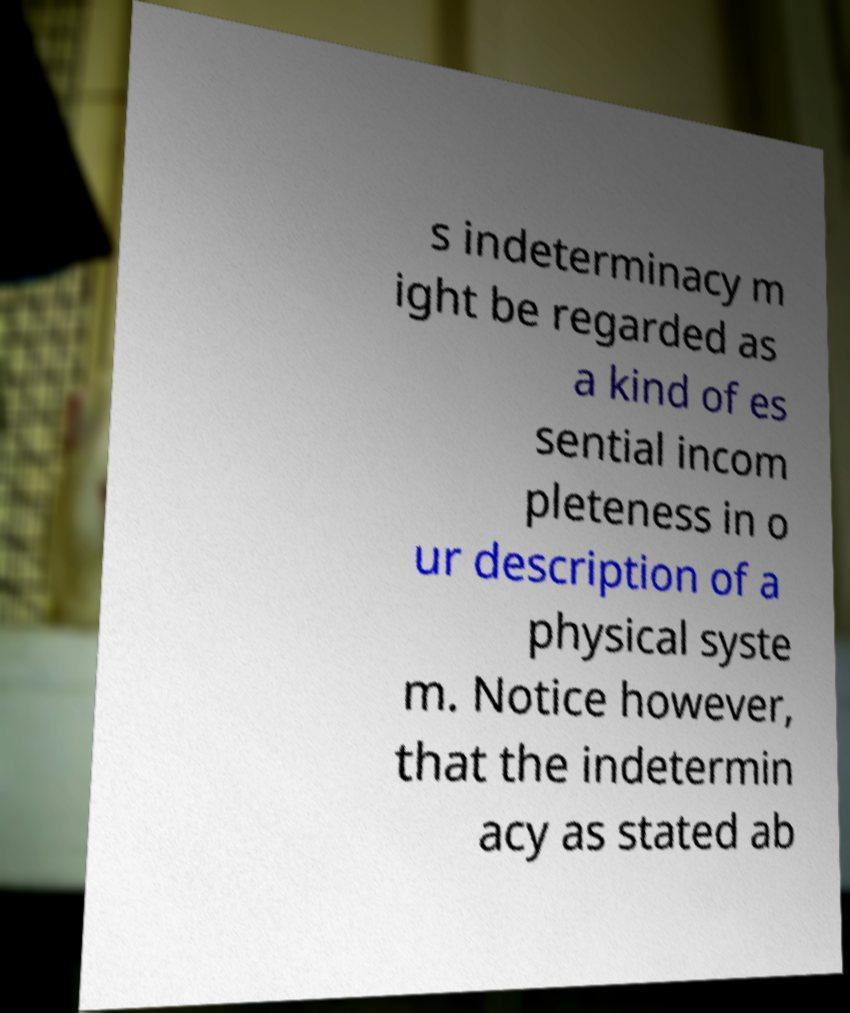Could you extract and type out the text from this image? s indeterminacy m ight be regarded as a kind of es sential incom pleteness in o ur description of a physical syste m. Notice however, that the indetermin acy as stated ab 